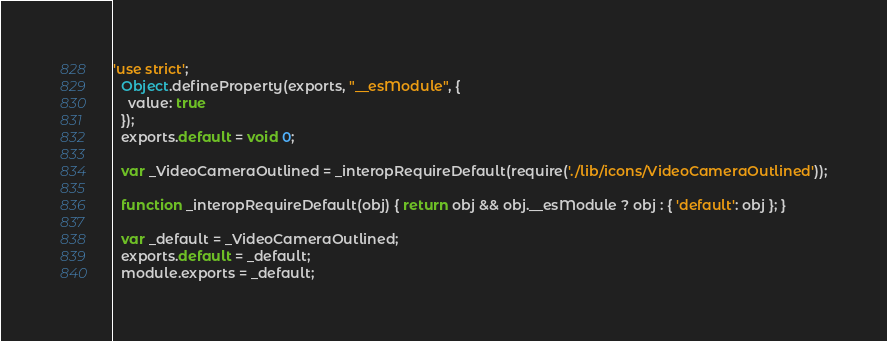<code> <loc_0><loc_0><loc_500><loc_500><_JavaScript_>'use strict';
  Object.defineProperty(exports, "__esModule", {
    value: true
  });
  exports.default = void 0;
  
  var _VideoCameraOutlined = _interopRequireDefault(require('./lib/icons/VideoCameraOutlined'));
  
  function _interopRequireDefault(obj) { return obj && obj.__esModule ? obj : { 'default': obj }; }
  
  var _default = _VideoCameraOutlined;
  exports.default = _default;
  module.exports = _default;</code> 